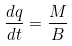<formula> <loc_0><loc_0><loc_500><loc_500>\frac { d q } { d t } = \frac { M } { B }</formula> 